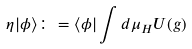<formula> <loc_0><loc_0><loc_500><loc_500>\eta | \phi \rangle \colon = \langle \phi | \int d \mu _ { H } U ( g )</formula> 